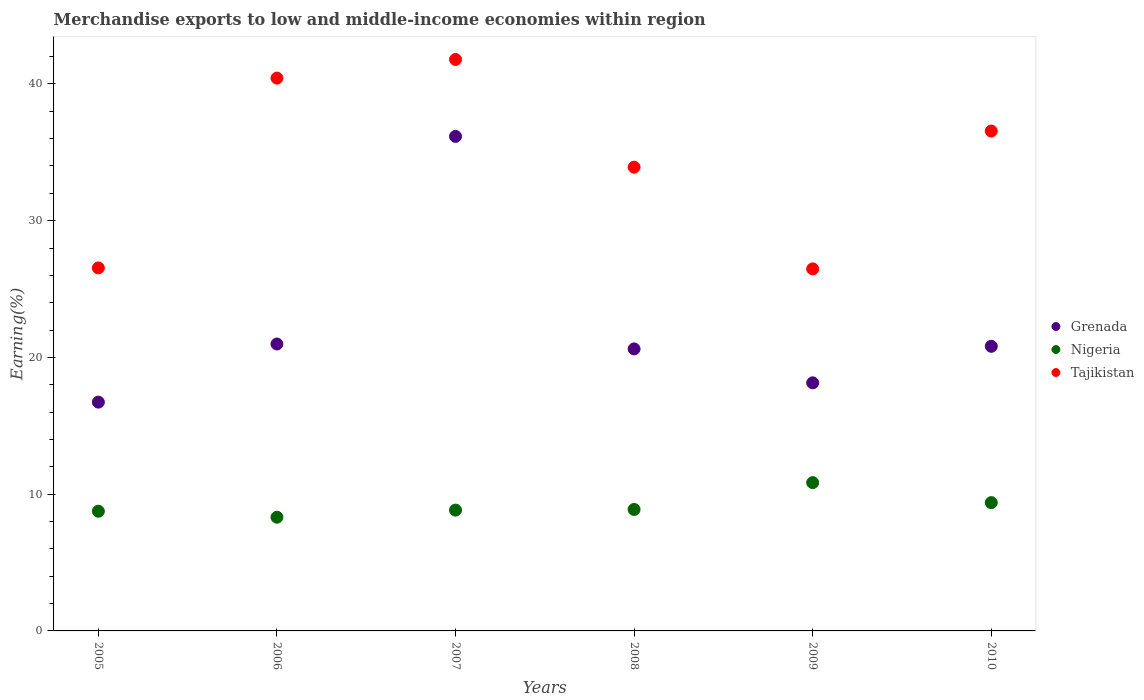Is the number of dotlines equal to the number of legend labels?
Offer a terse response. Yes. What is the percentage of amount earned from merchandise exports in Grenada in 2010?
Your answer should be compact. 20.81. Across all years, what is the maximum percentage of amount earned from merchandise exports in Nigeria?
Provide a succinct answer. 10.84. Across all years, what is the minimum percentage of amount earned from merchandise exports in Grenada?
Provide a short and direct response. 16.73. What is the total percentage of amount earned from merchandise exports in Tajikistan in the graph?
Offer a terse response. 205.7. What is the difference between the percentage of amount earned from merchandise exports in Nigeria in 2005 and that in 2010?
Your answer should be compact. -0.63. What is the difference between the percentage of amount earned from merchandise exports in Grenada in 2006 and the percentage of amount earned from merchandise exports in Tajikistan in 2008?
Give a very brief answer. -12.93. What is the average percentage of amount earned from merchandise exports in Grenada per year?
Give a very brief answer. 22.24. In the year 2009, what is the difference between the percentage of amount earned from merchandise exports in Grenada and percentage of amount earned from merchandise exports in Tajikistan?
Provide a succinct answer. -8.33. In how many years, is the percentage of amount earned from merchandise exports in Grenada greater than 40 %?
Offer a very short reply. 0. What is the ratio of the percentage of amount earned from merchandise exports in Tajikistan in 2005 to that in 2006?
Offer a very short reply. 0.66. Is the difference between the percentage of amount earned from merchandise exports in Grenada in 2005 and 2009 greater than the difference between the percentage of amount earned from merchandise exports in Tajikistan in 2005 and 2009?
Keep it short and to the point. No. What is the difference between the highest and the second highest percentage of amount earned from merchandise exports in Nigeria?
Provide a succinct answer. 1.46. What is the difference between the highest and the lowest percentage of amount earned from merchandise exports in Tajikistan?
Make the answer very short. 15.31. In how many years, is the percentage of amount earned from merchandise exports in Grenada greater than the average percentage of amount earned from merchandise exports in Grenada taken over all years?
Offer a terse response. 1. Is the sum of the percentage of amount earned from merchandise exports in Nigeria in 2008 and 2009 greater than the maximum percentage of amount earned from merchandise exports in Grenada across all years?
Provide a succinct answer. No. Does the percentage of amount earned from merchandise exports in Tajikistan monotonically increase over the years?
Make the answer very short. No. Is the percentage of amount earned from merchandise exports in Grenada strictly greater than the percentage of amount earned from merchandise exports in Nigeria over the years?
Offer a terse response. Yes. How many dotlines are there?
Your answer should be compact. 3. How many years are there in the graph?
Ensure brevity in your answer.  6. What is the difference between two consecutive major ticks on the Y-axis?
Provide a short and direct response. 10. Does the graph contain any zero values?
Offer a very short reply. No. How many legend labels are there?
Ensure brevity in your answer.  3. What is the title of the graph?
Ensure brevity in your answer.  Merchandise exports to low and middle-income economies within region. What is the label or title of the Y-axis?
Provide a short and direct response. Earning(%). What is the Earning(%) in Grenada in 2005?
Make the answer very short. 16.73. What is the Earning(%) in Nigeria in 2005?
Make the answer very short. 8.75. What is the Earning(%) of Tajikistan in 2005?
Keep it short and to the point. 26.54. What is the Earning(%) of Grenada in 2006?
Keep it short and to the point. 20.98. What is the Earning(%) in Nigeria in 2006?
Keep it short and to the point. 8.31. What is the Earning(%) in Tajikistan in 2006?
Your answer should be compact. 40.43. What is the Earning(%) in Grenada in 2007?
Your answer should be compact. 36.16. What is the Earning(%) of Nigeria in 2007?
Offer a terse response. 8.83. What is the Earning(%) of Tajikistan in 2007?
Offer a terse response. 41.79. What is the Earning(%) of Grenada in 2008?
Make the answer very short. 20.62. What is the Earning(%) of Nigeria in 2008?
Provide a short and direct response. 8.88. What is the Earning(%) in Tajikistan in 2008?
Offer a very short reply. 33.91. What is the Earning(%) in Grenada in 2009?
Provide a short and direct response. 18.14. What is the Earning(%) in Nigeria in 2009?
Give a very brief answer. 10.84. What is the Earning(%) of Tajikistan in 2009?
Your answer should be compact. 26.48. What is the Earning(%) in Grenada in 2010?
Your answer should be compact. 20.81. What is the Earning(%) of Nigeria in 2010?
Ensure brevity in your answer.  9.38. What is the Earning(%) of Tajikistan in 2010?
Your response must be concise. 36.56. Across all years, what is the maximum Earning(%) in Grenada?
Offer a terse response. 36.16. Across all years, what is the maximum Earning(%) of Nigeria?
Keep it short and to the point. 10.84. Across all years, what is the maximum Earning(%) of Tajikistan?
Offer a very short reply. 41.79. Across all years, what is the minimum Earning(%) in Grenada?
Provide a short and direct response. 16.73. Across all years, what is the minimum Earning(%) in Nigeria?
Offer a terse response. 8.31. Across all years, what is the minimum Earning(%) in Tajikistan?
Give a very brief answer. 26.48. What is the total Earning(%) of Grenada in the graph?
Your response must be concise. 133.45. What is the total Earning(%) in Nigeria in the graph?
Offer a terse response. 55.01. What is the total Earning(%) in Tajikistan in the graph?
Provide a short and direct response. 205.7. What is the difference between the Earning(%) in Grenada in 2005 and that in 2006?
Keep it short and to the point. -4.25. What is the difference between the Earning(%) in Nigeria in 2005 and that in 2006?
Provide a succinct answer. 0.44. What is the difference between the Earning(%) in Tajikistan in 2005 and that in 2006?
Offer a terse response. -13.88. What is the difference between the Earning(%) of Grenada in 2005 and that in 2007?
Give a very brief answer. -19.43. What is the difference between the Earning(%) in Nigeria in 2005 and that in 2007?
Offer a very short reply. -0.08. What is the difference between the Earning(%) of Tajikistan in 2005 and that in 2007?
Ensure brevity in your answer.  -15.25. What is the difference between the Earning(%) of Grenada in 2005 and that in 2008?
Give a very brief answer. -3.89. What is the difference between the Earning(%) of Nigeria in 2005 and that in 2008?
Provide a succinct answer. -0.13. What is the difference between the Earning(%) in Tajikistan in 2005 and that in 2008?
Your answer should be compact. -7.37. What is the difference between the Earning(%) of Grenada in 2005 and that in 2009?
Keep it short and to the point. -1.41. What is the difference between the Earning(%) in Nigeria in 2005 and that in 2009?
Offer a terse response. -2.09. What is the difference between the Earning(%) in Tajikistan in 2005 and that in 2009?
Your response must be concise. 0.07. What is the difference between the Earning(%) in Grenada in 2005 and that in 2010?
Offer a terse response. -4.08. What is the difference between the Earning(%) of Nigeria in 2005 and that in 2010?
Your answer should be compact. -0.63. What is the difference between the Earning(%) of Tajikistan in 2005 and that in 2010?
Your answer should be compact. -10.01. What is the difference between the Earning(%) in Grenada in 2006 and that in 2007?
Your response must be concise. -15.18. What is the difference between the Earning(%) in Nigeria in 2006 and that in 2007?
Ensure brevity in your answer.  -0.52. What is the difference between the Earning(%) in Tajikistan in 2006 and that in 2007?
Offer a terse response. -1.36. What is the difference between the Earning(%) in Grenada in 2006 and that in 2008?
Keep it short and to the point. 0.36. What is the difference between the Earning(%) of Nigeria in 2006 and that in 2008?
Offer a terse response. -0.57. What is the difference between the Earning(%) of Tajikistan in 2006 and that in 2008?
Your answer should be very brief. 6.51. What is the difference between the Earning(%) in Grenada in 2006 and that in 2009?
Your response must be concise. 2.84. What is the difference between the Earning(%) of Nigeria in 2006 and that in 2009?
Provide a short and direct response. -2.53. What is the difference between the Earning(%) of Tajikistan in 2006 and that in 2009?
Your answer should be very brief. 13.95. What is the difference between the Earning(%) of Grenada in 2006 and that in 2010?
Your response must be concise. 0.17. What is the difference between the Earning(%) of Nigeria in 2006 and that in 2010?
Give a very brief answer. -1.07. What is the difference between the Earning(%) of Tajikistan in 2006 and that in 2010?
Offer a very short reply. 3.87. What is the difference between the Earning(%) of Grenada in 2007 and that in 2008?
Make the answer very short. 15.54. What is the difference between the Earning(%) in Nigeria in 2007 and that in 2008?
Offer a very short reply. -0.05. What is the difference between the Earning(%) of Tajikistan in 2007 and that in 2008?
Provide a short and direct response. 7.88. What is the difference between the Earning(%) in Grenada in 2007 and that in 2009?
Provide a short and direct response. 18.02. What is the difference between the Earning(%) in Nigeria in 2007 and that in 2009?
Offer a terse response. -2.01. What is the difference between the Earning(%) in Tajikistan in 2007 and that in 2009?
Give a very brief answer. 15.31. What is the difference between the Earning(%) of Grenada in 2007 and that in 2010?
Ensure brevity in your answer.  15.35. What is the difference between the Earning(%) in Nigeria in 2007 and that in 2010?
Ensure brevity in your answer.  -0.55. What is the difference between the Earning(%) in Tajikistan in 2007 and that in 2010?
Give a very brief answer. 5.23. What is the difference between the Earning(%) in Grenada in 2008 and that in 2009?
Give a very brief answer. 2.48. What is the difference between the Earning(%) of Nigeria in 2008 and that in 2009?
Keep it short and to the point. -1.96. What is the difference between the Earning(%) of Tajikistan in 2008 and that in 2009?
Make the answer very short. 7.44. What is the difference between the Earning(%) in Grenada in 2008 and that in 2010?
Give a very brief answer. -0.19. What is the difference between the Earning(%) of Nigeria in 2008 and that in 2010?
Ensure brevity in your answer.  -0.5. What is the difference between the Earning(%) of Tajikistan in 2008 and that in 2010?
Ensure brevity in your answer.  -2.64. What is the difference between the Earning(%) of Grenada in 2009 and that in 2010?
Provide a short and direct response. -2.67. What is the difference between the Earning(%) in Nigeria in 2009 and that in 2010?
Offer a terse response. 1.46. What is the difference between the Earning(%) of Tajikistan in 2009 and that in 2010?
Give a very brief answer. -10.08. What is the difference between the Earning(%) of Grenada in 2005 and the Earning(%) of Nigeria in 2006?
Ensure brevity in your answer.  8.42. What is the difference between the Earning(%) of Grenada in 2005 and the Earning(%) of Tajikistan in 2006?
Provide a succinct answer. -23.69. What is the difference between the Earning(%) of Nigeria in 2005 and the Earning(%) of Tajikistan in 2006?
Make the answer very short. -31.67. What is the difference between the Earning(%) of Grenada in 2005 and the Earning(%) of Nigeria in 2007?
Make the answer very short. 7.9. What is the difference between the Earning(%) in Grenada in 2005 and the Earning(%) in Tajikistan in 2007?
Your response must be concise. -25.06. What is the difference between the Earning(%) in Nigeria in 2005 and the Earning(%) in Tajikistan in 2007?
Your response must be concise. -33.04. What is the difference between the Earning(%) in Grenada in 2005 and the Earning(%) in Nigeria in 2008?
Your answer should be compact. 7.85. What is the difference between the Earning(%) in Grenada in 2005 and the Earning(%) in Tajikistan in 2008?
Provide a short and direct response. -17.18. What is the difference between the Earning(%) of Nigeria in 2005 and the Earning(%) of Tajikistan in 2008?
Give a very brief answer. -25.16. What is the difference between the Earning(%) in Grenada in 2005 and the Earning(%) in Nigeria in 2009?
Your answer should be very brief. 5.89. What is the difference between the Earning(%) of Grenada in 2005 and the Earning(%) of Tajikistan in 2009?
Offer a very short reply. -9.74. What is the difference between the Earning(%) in Nigeria in 2005 and the Earning(%) in Tajikistan in 2009?
Your response must be concise. -17.72. What is the difference between the Earning(%) of Grenada in 2005 and the Earning(%) of Nigeria in 2010?
Provide a succinct answer. 7.35. What is the difference between the Earning(%) of Grenada in 2005 and the Earning(%) of Tajikistan in 2010?
Make the answer very short. -19.82. What is the difference between the Earning(%) in Nigeria in 2005 and the Earning(%) in Tajikistan in 2010?
Provide a short and direct response. -27.8. What is the difference between the Earning(%) in Grenada in 2006 and the Earning(%) in Nigeria in 2007?
Provide a succinct answer. 12.15. What is the difference between the Earning(%) in Grenada in 2006 and the Earning(%) in Tajikistan in 2007?
Keep it short and to the point. -20.81. What is the difference between the Earning(%) of Nigeria in 2006 and the Earning(%) of Tajikistan in 2007?
Keep it short and to the point. -33.47. What is the difference between the Earning(%) of Grenada in 2006 and the Earning(%) of Tajikistan in 2008?
Offer a terse response. -12.93. What is the difference between the Earning(%) of Nigeria in 2006 and the Earning(%) of Tajikistan in 2008?
Your answer should be very brief. -25.6. What is the difference between the Earning(%) in Grenada in 2006 and the Earning(%) in Nigeria in 2009?
Make the answer very short. 10.14. What is the difference between the Earning(%) in Grenada in 2006 and the Earning(%) in Tajikistan in 2009?
Offer a terse response. -5.49. What is the difference between the Earning(%) of Nigeria in 2006 and the Earning(%) of Tajikistan in 2009?
Your answer should be very brief. -18.16. What is the difference between the Earning(%) in Grenada in 2006 and the Earning(%) in Nigeria in 2010?
Give a very brief answer. 11.6. What is the difference between the Earning(%) in Grenada in 2006 and the Earning(%) in Tajikistan in 2010?
Offer a very short reply. -15.57. What is the difference between the Earning(%) of Nigeria in 2006 and the Earning(%) of Tajikistan in 2010?
Provide a short and direct response. -28.24. What is the difference between the Earning(%) of Grenada in 2007 and the Earning(%) of Nigeria in 2008?
Your answer should be very brief. 27.28. What is the difference between the Earning(%) in Grenada in 2007 and the Earning(%) in Tajikistan in 2008?
Make the answer very short. 2.25. What is the difference between the Earning(%) of Nigeria in 2007 and the Earning(%) of Tajikistan in 2008?
Provide a short and direct response. -25.08. What is the difference between the Earning(%) of Grenada in 2007 and the Earning(%) of Nigeria in 2009?
Ensure brevity in your answer.  25.32. What is the difference between the Earning(%) of Grenada in 2007 and the Earning(%) of Tajikistan in 2009?
Your response must be concise. 9.69. What is the difference between the Earning(%) of Nigeria in 2007 and the Earning(%) of Tajikistan in 2009?
Provide a succinct answer. -17.64. What is the difference between the Earning(%) in Grenada in 2007 and the Earning(%) in Nigeria in 2010?
Give a very brief answer. 26.78. What is the difference between the Earning(%) of Grenada in 2007 and the Earning(%) of Tajikistan in 2010?
Make the answer very short. -0.39. What is the difference between the Earning(%) in Nigeria in 2007 and the Earning(%) in Tajikistan in 2010?
Provide a succinct answer. -27.72. What is the difference between the Earning(%) in Grenada in 2008 and the Earning(%) in Nigeria in 2009?
Keep it short and to the point. 9.78. What is the difference between the Earning(%) in Grenada in 2008 and the Earning(%) in Tajikistan in 2009?
Your response must be concise. -5.85. What is the difference between the Earning(%) in Nigeria in 2008 and the Earning(%) in Tajikistan in 2009?
Make the answer very short. -17.59. What is the difference between the Earning(%) of Grenada in 2008 and the Earning(%) of Nigeria in 2010?
Offer a very short reply. 11.24. What is the difference between the Earning(%) of Grenada in 2008 and the Earning(%) of Tajikistan in 2010?
Provide a short and direct response. -15.93. What is the difference between the Earning(%) in Nigeria in 2008 and the Earning(%) in Tajikistan in 2010?
Give a very brief answer. -27.67. What is the difference between the Earning(%) of Grenada in 2009 and the Earning(%) of Nigeria in 2010?
Offer a very short reply. 8.76. What is the difference between the Earning(%) in Grenada in 2009 and the Earning(%) in Tajikistan in 2010?
Offer a terse response. -18.41. What is the difference between the Earning(%) in Nigeria in 2009 and the Earning(%) in Tajikistan in 2010?
Ensure brevity in your answer.  -25.71. What is the average Earning(%) of Grenada per year?
Provide a short and direct response. 22.24. What is the average Earning(%) of Nigeria per year?
Your answer should be very brief. 9.17. What is the average Earning(%) in Tajikistan per year?
Your answer should be compact. 34.28. In the year 2005, what is the difference between the Earning(%) of Grenada and Earning(%) of Nigeria?
Provide a short and direct response. 7.98. In the year 2005, what is the difference between the Earning(%) of Grenada and Earning(%) of Tajikistan?
Make the answer very short. -9.81. In the year 2005, what is the difference between the Earning(%) of Nigeria and Earning(%) of Tajikistan?
Give a very brief answer. -17.79. In the year 2006, what is the difference between the Earning(%) of Grenada and Earning(%) of Nigeria?
Offer a terse response. 12.67. In the year 2006, what is the difference between the Earning(%) in Grenada and Earning(%) in Tajikistan?
Give a very brief answer. -19.44. In the year 2006, what is the difference between the Earning(%) of Nigeria and Earning(%) of Tajikistan?
Provide a succinct answer. -32.11. In the year 2007, what is the difference between the Earning(%) in Grenada and Earning(%) in Nigeria?
Offer a very short reply. 27.33. In the year 2007, what is the difference between the Earning(%) of Grenada and Earning(%) of Tajikistan?
Your answer should be compact. -5.63. In the year 2007, what is the difference between the Earning(%) of Nigeria and Earning(%) of Tajikistan?
Provide a succinct answer. -32.95. In the year 2008, what is the difference between the Earning(%) of Grenada and Earning(%) of Nigeria?
Offer a terse response. 11.74. In the year 2008, what is the difference between the Earning(%) of Grenada and Earning(%) of Tajikistan?
Keep it short and to the point. -13.29. In the year 2008, what is the difference between the Earning(%) in Nigeria and Earning(%) in Tajikistan?
Provide a succinct answer. -25.03. In the year 2009, what is the difference between the Earning(%) in Grenada and Earning(%) in Nigeria?
Your response must be concise. 7.3. In the year 2009, what is the difference between the Earning(%) of Grenada and Earning(%) of Tajikistan?
Your answer should be compact. -8.33. In the year 2009, what is the difference between the Earning(%) of Nigeria and Earning(%) of Tajikistan?
Make the answer very short. -15.63. In the year 2010, what is the difference between the Earning(%) in Grenada and Earning(%) in Nigeria?
Provide a short and direct response. 11.43. In the year 2010, what is the difference between the Earning(%) in Grenada and Earning(%) in Tajikistan?
Provide a succinct answer. -15.74. In the year 2010, what is the difference between the Earning(%) of Nigeria and Earning(%) of Tajikistan?
Keep it short and to the point. -27.17. What is the ratio of the Earning(%) of Grenada in 2005 to that in 2006?
Make the answer very short. 0.8. What is the ratio of the Earning(%) in Nigeria in 2005 to that in 2006?
Ensure brevity in your answer.  1.05. What is the ratio of the Earning(%) in Tajikistan in 2005 to that in 2006?
Your answer should be very brief. 0.66. What is the ratio of the Earning(%) in Grenada in 2005 to that in 2007?
Your response must be concise. 0.46. What is the ratio of the Earning(%) of Nigeria in 2005 to that in 2007?
Provide a succinct answer. 0.99. What is the ratio of the Earning(%) of Tajikistan in 2005 to that in 2007?
Keep it short and to the point. 0.64. What is the ratio of the Earning(%) of Grenada in 2005 to that in 2008?
Provide a short and direct response. 0.81. What is the ratio of the Earning(%) of Nigeria in 2005 to that in 2008?
Your response must be concise. 0.99. What is the ratio of the Earning(%) in Tajikistan in 2005 to that in 2008?
Your response must be concise. 0.78. What is the ratio of the Earning(%) in Grenada in 2005 to that in 2009?
Provide a succinct answer. 0.92. What is the ratio of the Earning(%) in Nigeria in 2005 to that in 2009?
Ensure brevity in your answer.  0.81. What is the ratio of the Earning(%) in Tajikistan in 2005 to that in 2009?
Your answer should be very brief. 1. What is the ratio of the Earning(%) of Grenada in 2005 to that in 2010?
Offer a terse response. 0.8. What is the ratio of the Earning(%) of Nigeria in 2005 to that in 2010?
Offer a terse response. 0.93. What is the ratio of the Earning(%) in Tajikistan in 2005 to that in 2010?
Your answer should be compact. 0.73. What is the ratio of the Earning(%) of Grenada in 2006 to that in 2007?
Provide a succinct answer. 0.58. What is the ratio of the Earning(%) of Nigeria in 2006 to that in 2007?
Make the answer very short. 0.94. What is the ratio of the Earning(%) in Tajikistan in 2006 to that in 2007?
Provide a short and direct response. 0.97. What is the ratio of the Earning(%) of Grenada in 2006 to that in 2008?
Give a very brief answer. 1.02. What is the ratio of the Earning(%) of Nigeria in 2006 to that in 2008?
Your answer should be very brief. 0.94. What is the ratio of the Earning(%) of Tajikistan in 2006 to that in 2008?
Provide a succinct answer. 1.19. What is the ratio of the Earning(%) of Grenada in 2006 to that in 2009?
Your answer should be very brief. 1.16. What is the ratio of the Earning(%) in Nigeria in 2006 to that in 2009?
Ensure brevity in your answer.  0.77. What is the ratio of the Earning(%) in Tajikistan in 2006 to that in 2009?
Keep it short and to the point. 1.53. What is the ratio of the Earning(%) of Grenada in 2006 to that in 2010?
Your response must be concise. 1.01. What is the ratio of the Earning(%) in Nigeria in 2006 to that in 2010?
Your answer should be compact. 0.89. What is the ratio of the Earning(%) of Tajikistan in 2006 to that in 2010?
Your answer should be very brief. 1.11. What is the ratio of the Earning(%) of Grenada in 2007 to that in 2008?
Keep it short and to the point. 1.75. What is the ratio of the Earning(%) in Nigeria in 2007 to that in 2008?
Offer a terse response. 0.99. What is the ratio of the Earning(%) in Tajikistan in 2007 to that in 2008?
Provide a short and direct response. 1.23. What is the ratio of the Earning(%) in Grenada in 2007 to that in 2009?
Offer a very short reply. 1.99. What is the ratio of the Earning(%) of Nigeria in 2007 to that in 2009?
Your answer should be very brief. 0.81. What is the ratio of the Earning(%) in Tajikistan in 2007 to that in 2009?
Provide a short and direct response. 1.58. What is the ratio of the Earning(%) of Grenada in 2007 to that in 2010?
Offer a terse response. 1.74. What is the ratio of the Earning(%) in Nigeria in 2007 to that in 2010?
Make the answer very short. 0.94. What is the ratio of the Earning(%) of Tajikistan in 2007 to that in 2010?
Your answer should be compact. 1.14. What is the ratio of the Earning(%) of Grenada in 2008 to that in 2009?
Ensure brevity in your answer.  1.14. What is the ratio of the Earning(%) of Nigeria in 2008 to that in 2009?
Your answer should be very brief. 0.82. What is the ratio of the Earning(%) in Tajikistan in 2008 to that in 2009?
Provide a succinct answer. 1.28. What is the ratio of the Earning(%) of Nigeria in 2008 to that in 2010?
Provide a succinct answer. 0.95. What is the ratio of the Earning(%) in Tajikistan in 2008 to that in 2010?
Keep it short and to the point. 0.93. What is the ratio of the Earning(%) in Grenada in 2009 to that in 2010?
Your response must be concise. 0.87. What is the ratio of the Earning(%) in Nigeria in 2009 to that in 2010?
Your response must be concise. 1.16. What is the ratio of the Earning(%) in Tajikistan in 2009 to that in 2010?
Your response must be concise. 0.72. What is the difference between the highest and the second highest Earning(%) of Grenada?
Provide a succinct answer. 15.18. What is the difference between the highest and the second highest Earning(%) of Nigeria?
Offer a terse response. 1.46. What is the difference between the highest and the second highest Earning(%) in Tajikistan?
Offer a terse response. 1.36. What is the difference between the highest and the lowest Earning(%) in Grenada?
Provide a short and direct response. 19.43. What is the difference between the highest and the lowest Earning(%) in Nigeria?
Provide a succinct answer. 2.53. What is the difference between the highest and the lowest Earning(%) in Tajikistan?
Make the answer very short. 15.31. 